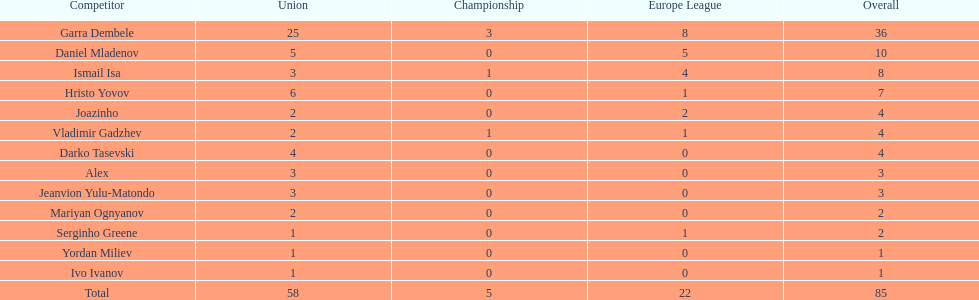How many of the players did not score any goals in the cup? 10. 